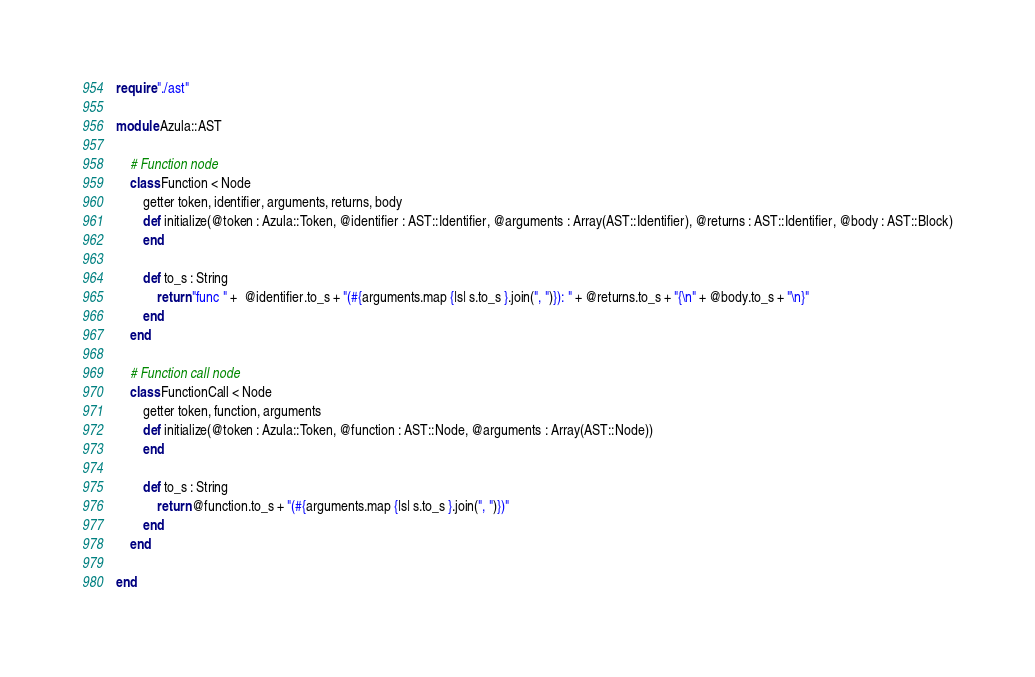<code> <loc_0><loc_0><loc_500><loc_500><_Crystal_>require "./ast"

module Azula::AST

    # Function node
    class Function < Node
        getter token, identifier, arguments, returns, body
        def initialize(@token : Azula::Token, @identifier : AST::Identifier, @arguments : Array(AST::Identifier), @returns : AST::Identifier, @body : AST::Block)
        end

        def to_s : String
            return "func " +  @identifier.to_s + "(#{arguments.map {|s| s.to_s }.join(", ")}): " + @returns.to_s + "{\n" + @body.to_s + "\n}"
        end
    end

    # Function call node
    class FunctionCall < Node
        getter token, function, arguments
        def initialize(@token : Azula::Token, @function : AST::Node, @arguments : Array(AST::Node))
        end

        def to_s : String
            return @function.to_s + "(#{arguments.map {|s| s.to_s }.join(", ")})"
        end
    end

end</code> 